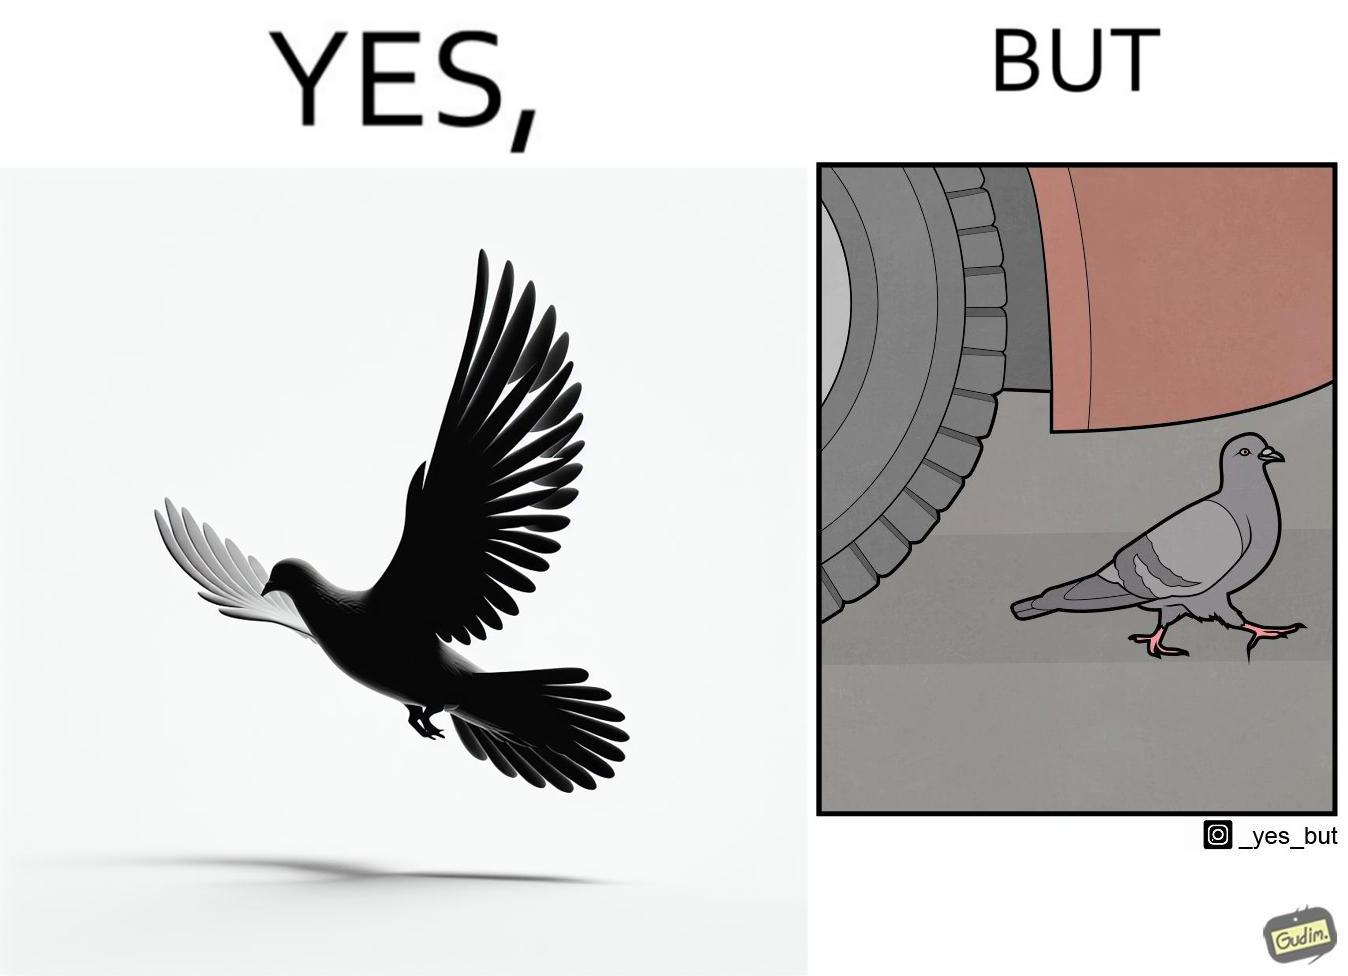Describe the contrast between the left and right parts of this image. In the left part of the image: a grey pigeon flying in the sky In the right part of the image: a grey pigeon walking under a car 